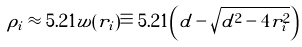<formula> <loc_0><loc_0><loc_500><loc_500>\rho _ { i } \approx 5 . 2 1 w ( r _ { i } ) \equiv 5 . 2 1 \left ( d - \sqrt { d ^ { 2 } - 4 r _ { i } ^ { 2 } } \right )</formula> 